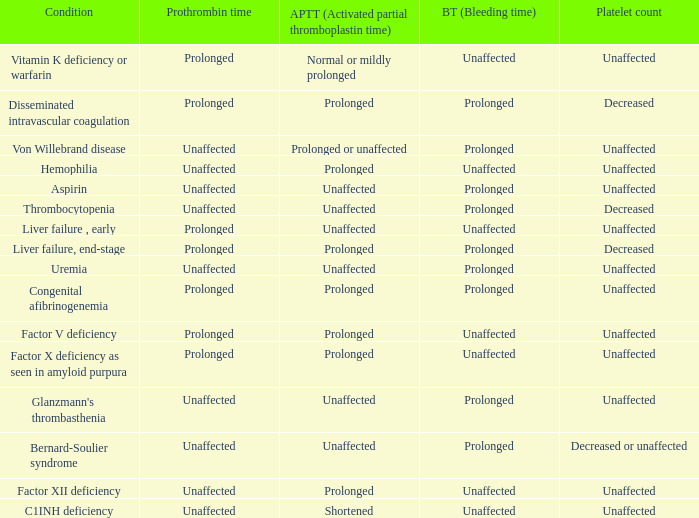Which Bleeding time has a Condition of factor x deficiency as seen in amyloid purpura? Unaffected. 